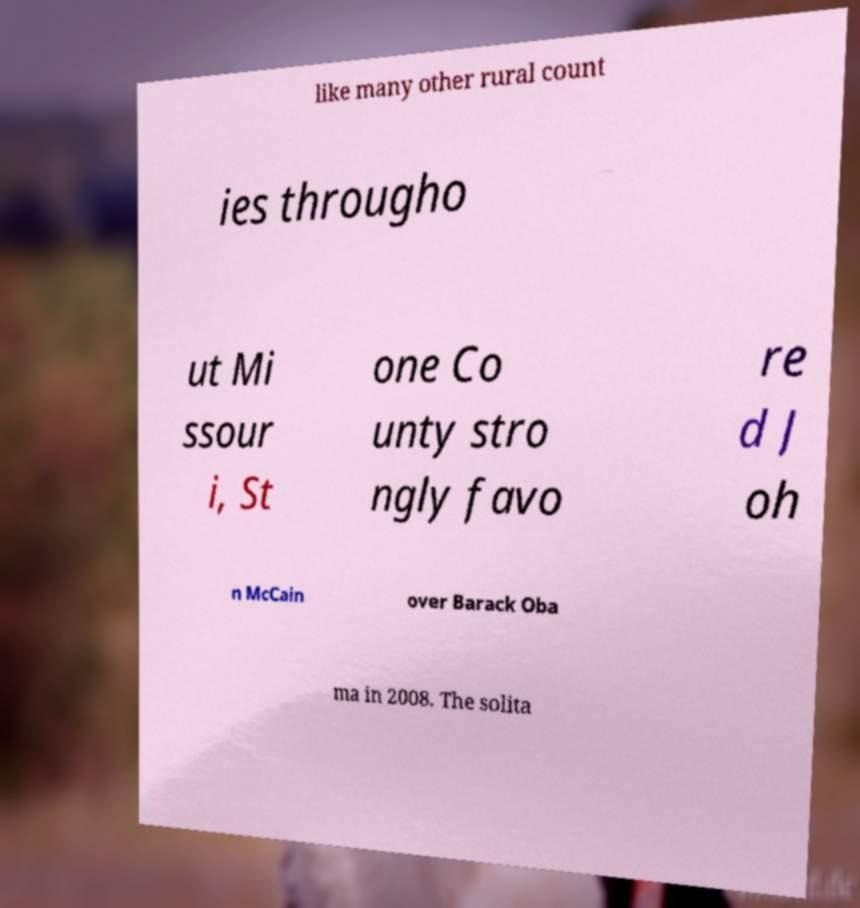Could you assist in decoding the text presented in this image and type it out clearly? like many other rural count ies througho ut Mi ssour i, St one Co unty stro ngly favo re d J oh n McCain over Barack Oba ma in 2008. The solita 